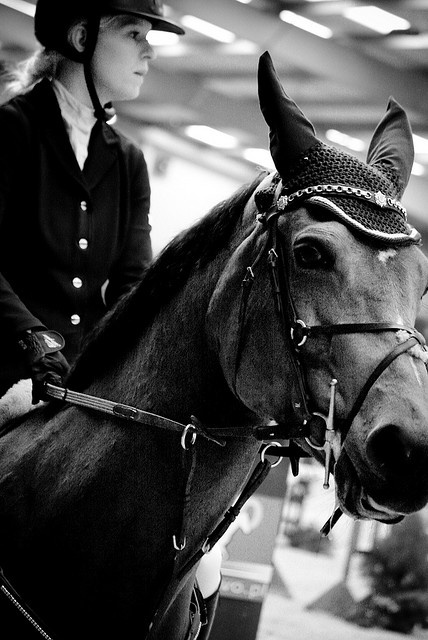Describe the objects in this image and their specific colors. I can see horse in lightgray, black, gray, darkgray, and gainsboro tones and people in lightgray, black, darkgray, and gray tones in this image. 